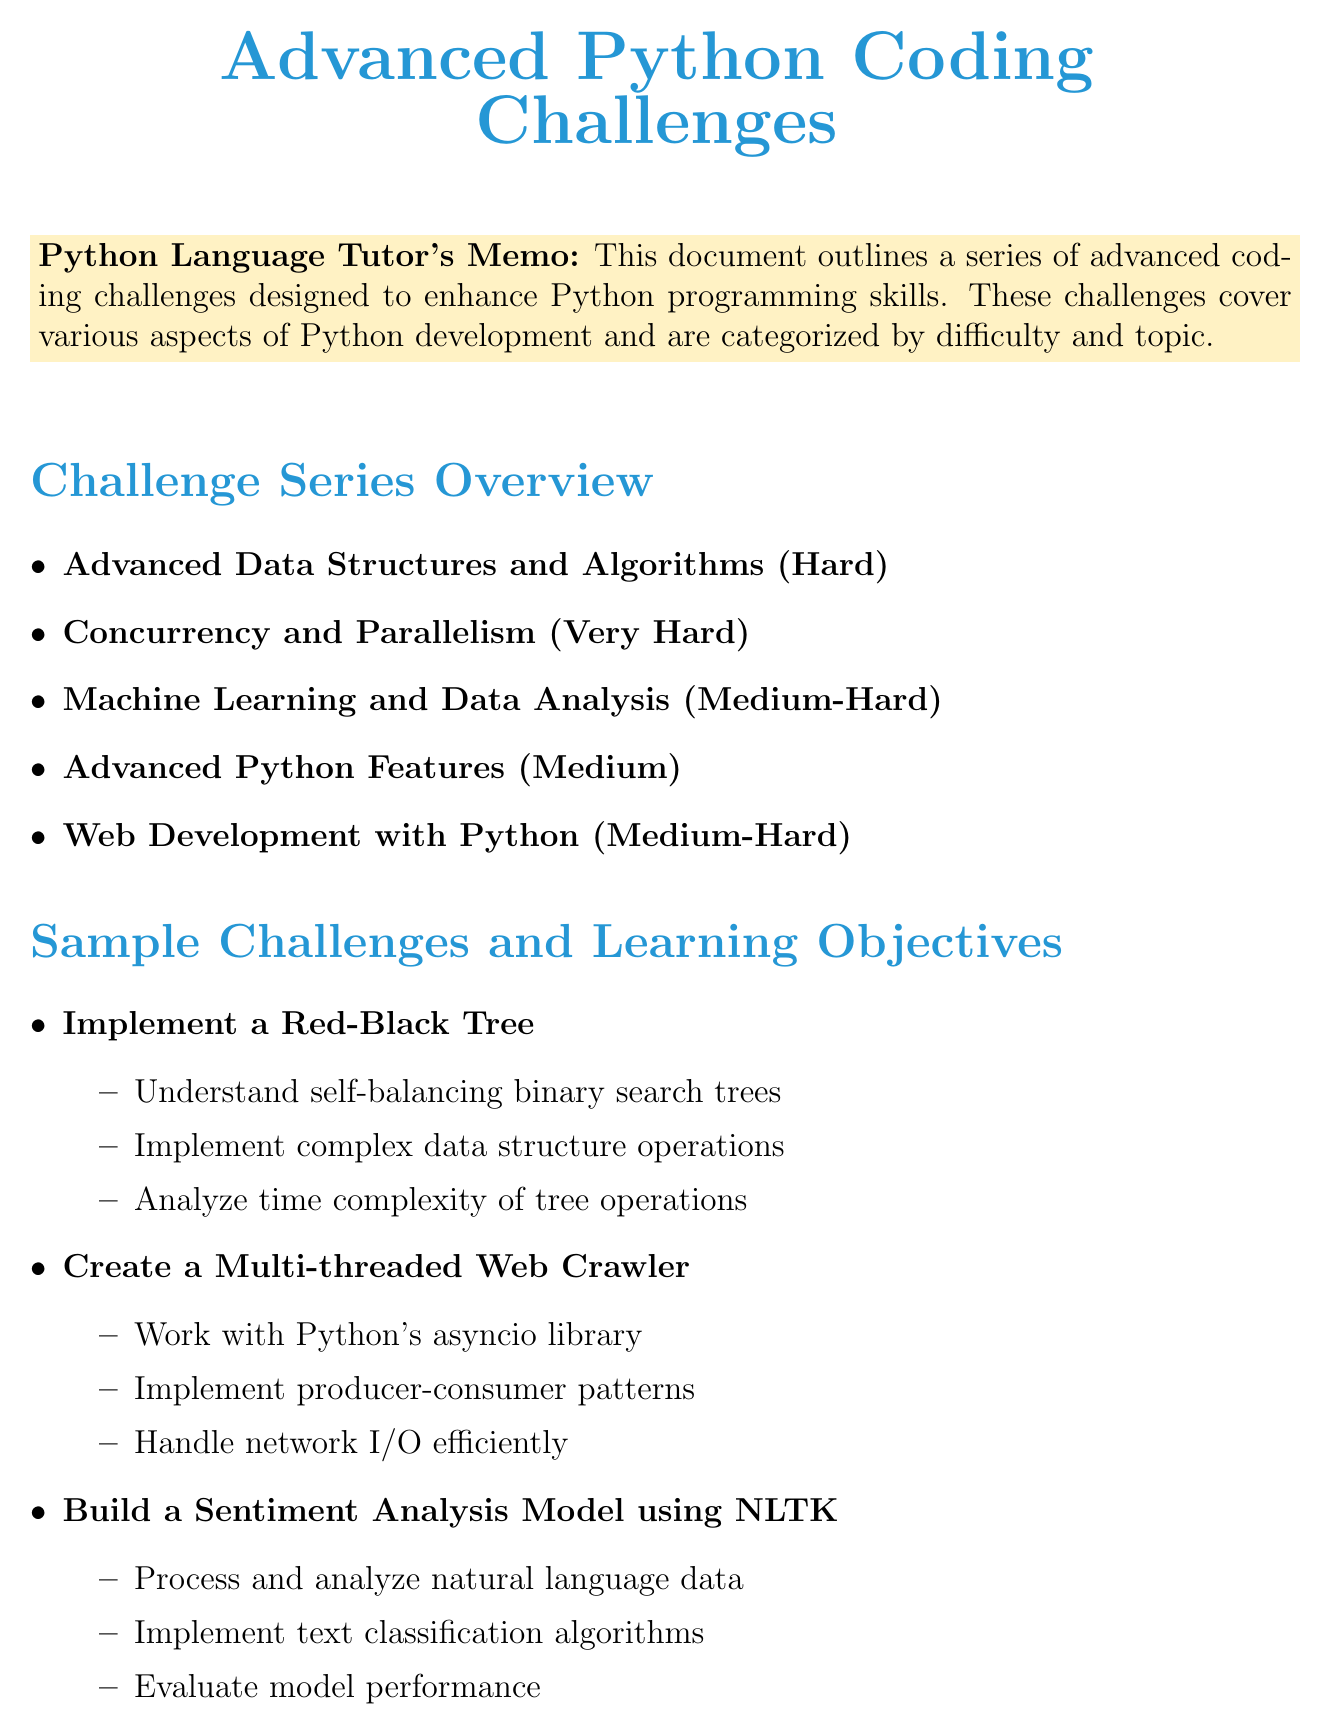What is the title of the first challenge series? The first challenge series is titled "Advanced Data Structures and Algorithms."
Answer: Advanced Data Structures and Algorithms What is the difficulty level of the "Concurrency and Parallelism" challenge series? The difficulty level is described as "Very Hard."
Answer: Very Hard How many learning objectives are listed for the challenge "Implement K-means Clustering from Scratch"? The document lists three learning objectives for this challenge.
Answer: Three What is the main focus of the "Advanced Python Features" challenge series? The main focus is on advanced concepts in Python, such as context managers and descriptors.
Answer: Advanced concepts in Python Which resource provides Python advanced documentation? The document mentions "Python Advanced Documentation" as a resource.
Answer: Python Advanced Documentation What is one of the evaluation criteria mentioned for the challenges? One of the evaluation criteria is "Code quality and adherence to PEP 8."
Answer: Code quality and adherence to PEP 8 How many total challenge series are listed in the document? There are five challenge series listed in total.
Answer: Five Which challenge involves building a chat application? The challenge that involves building a chat application is "Create a Real-time Chat Application using WebSockets."
Answer: Create a Real-time Chat Application using WebSockets 